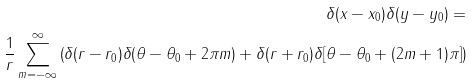<formula> <loc_0><loc_0><loc_500><loc_500>\delta ( x - x _ { 0 } ) \delta ( y - y _ { 0 } ) = \\ \frac { 1 } { r } \sum _ { m = - \infty } ^ { \infty } \left ( \delta ( r - r _ { 0 } ) \delta ( \theta - \theta _ { 0 } + 2 \pi m ) + \delta ( r + r _ { 0 } ) \delta [ \theta - \theta _ { 0 } + ( 2 m + 1 ) \pi ] \right )</formula> 